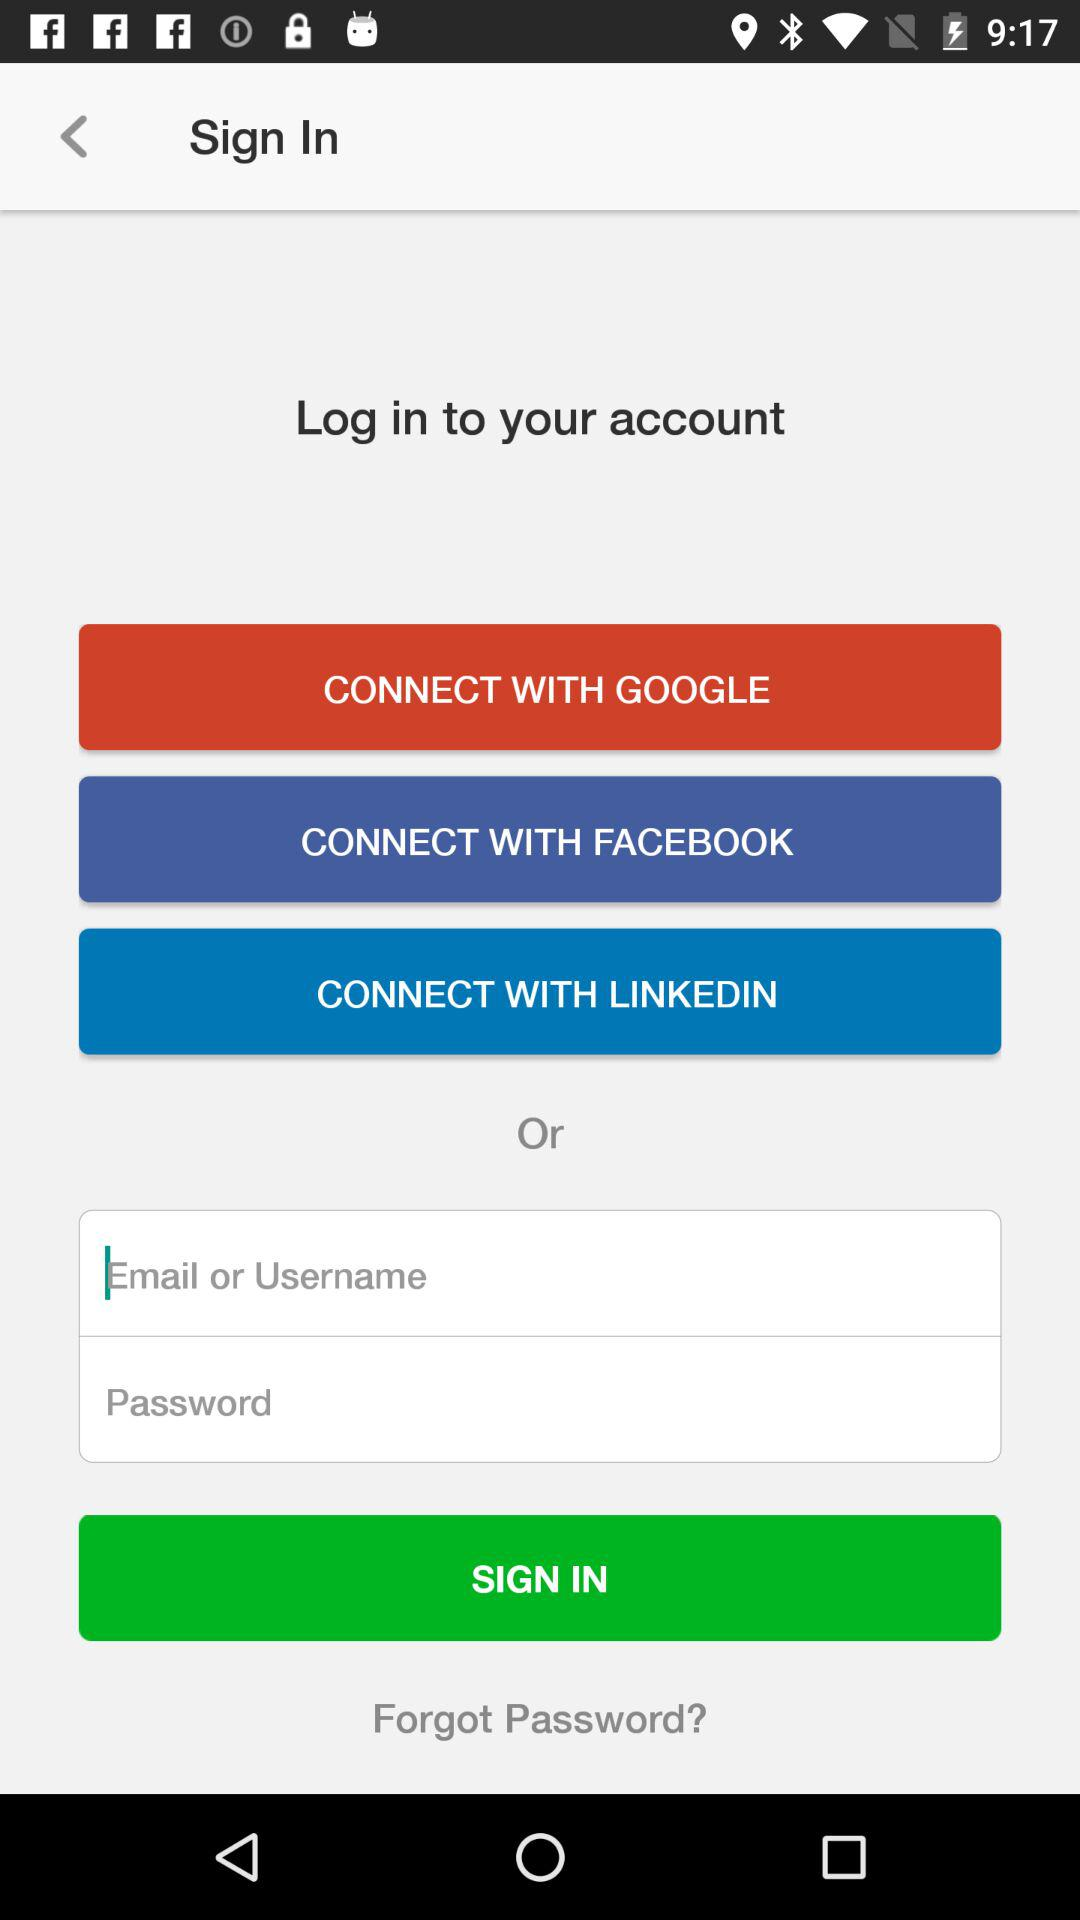Which application can be used to log in with? The applications that can be used to log in are "FACEBOOK", "GOOGLE" and "LINKEDIN". 